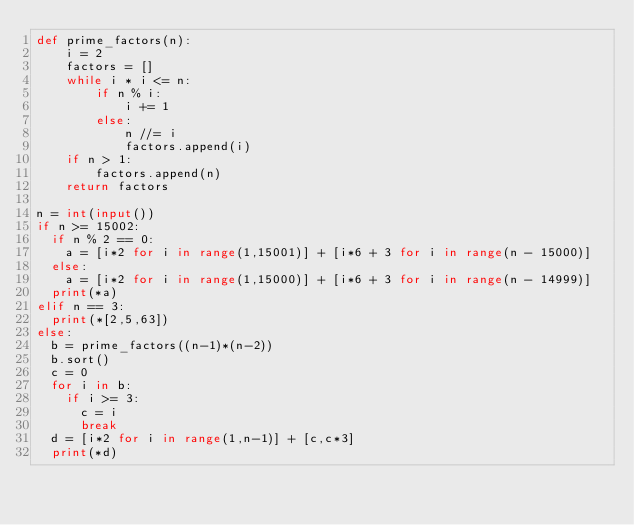<code> <loc_0><loc_0><loc_500><loc_500><_Python_>def prime_factors(n):
    i = 2
    factors = []
    while i * i <= n:
        if n % i:
            i += 1
        else:
            n //= i
            factors.append(i)
    if n > 1:
        factors.append(n)
    return factors

n = int(input())
if n >= 15002:
  if n % 2 == 0:
    a = [i*2 for i in range(1,15001)] + [i*6 + 3 for i in range(n - 15000)]
  else:
    a = [i*2 for i in range(1,15000)] + [i*6 + 3 for i in range(n - 14999)]
  print(*a)
elif n == 3:
  print(*[2,5,63])
else:
  b = prime_factors((n-1)*(n-2))
  b.sort()
  c = 0
  for i in b:
    if i >= 3:
      c = i
      break
  d = [i*2 for i in range(1,n-1)] + [c,c*3]
  print(*d)</code> 